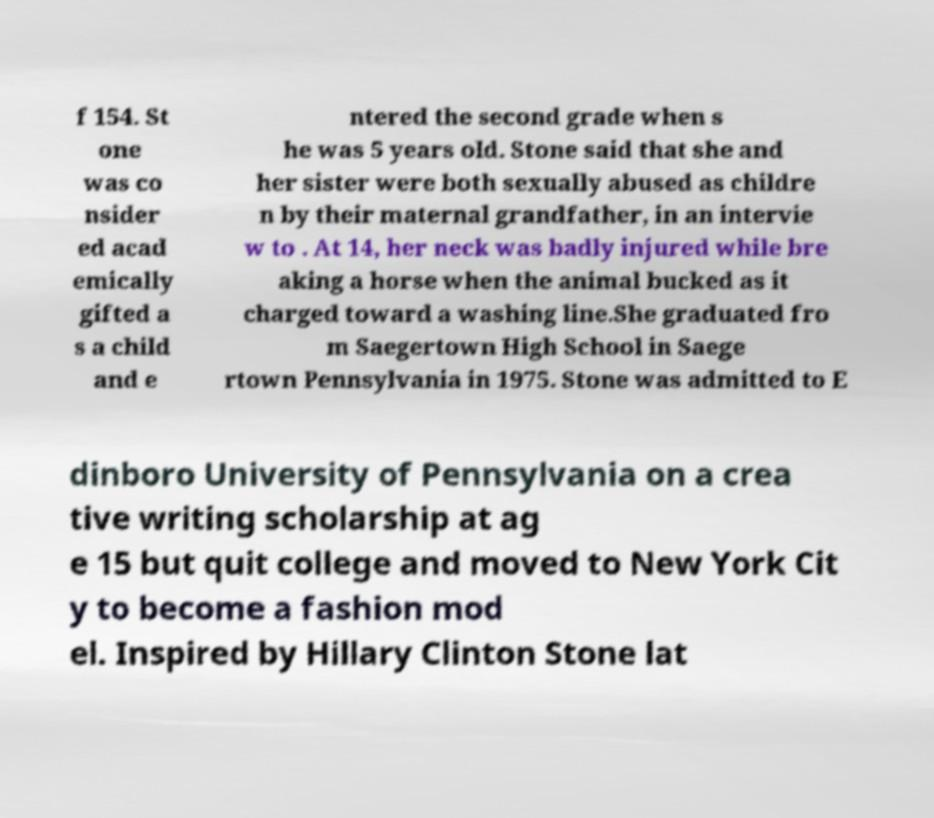Could you extract and type out the text from this image? f 154. St one was co nsider ed acad emically gifted a s a child and e ntered the second grade when s he was 5 years old. Stone said that she and her sister were both sexually abused as childre n by their maternal grandfather, in an intervie w to . At 14, her neck was badly injured while bre aking a horse when the animal bucked as it charged toward a washing line.She graduated fro m Saegertown High School in Saege rtown Pennsylvania in 1975. Stone was admitted to E dinboro University of Pennsylvania on a crea tive writing scholarship at ag e 15 but quit college and moved to New York Cit y to become a fashion mod el. Inspired by Hillary Clinton Stone lat 